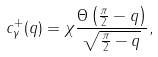<formula> <loc_0><loc_0><loc_500><loc_500>c ^ { + } _ { \gamma } ( q ) = \chi \frac { \Theta \left ( \frac { \pi } { 2 } - q \right ) } { \sqrt { \frac { \pi } { 2 } - q } } ,</formula> 